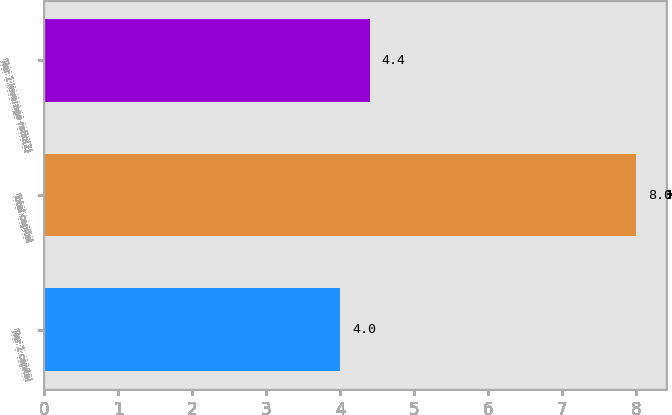<chart> <loc_0><loc_0><loc_500><loc_500><bar_chart><fcel>Tier 1 capital<fcel>Total capital<fcel>Tier 1 leverage ratio(2)<nl><fcel>4<fcel>8<fcel>4.4<nl></chart> 